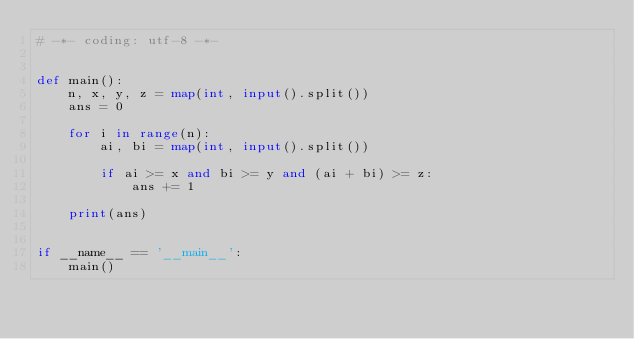<code> <loc_0><loc_0><loc_500><loc_500><_Python_># -*- coding: utf-8 -*-


def main():
    n, x, y, z = map(int, input().split())
    ans = 0

    for i in range(n):
        ai, bi = map(int, input().split())

        if ai >= x and bi >= y and (ai + bi) >= z:
            ans += 1

    print(ans)


if __name__ == '__main__':
    main()
</code> 